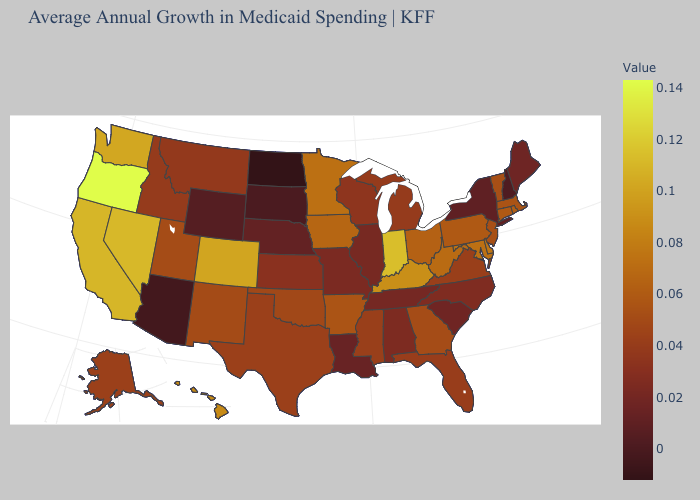Among the states that border Vermont , which have the highest value?
Answer briefly. Massachusetts. Does Utah have the highest value in the West?
Answer briefly. No. Does Nevada have the lowest value in the West?
Be succinct. No. Which states have the lowest value in the USA?
Short answer required. North Dakota. Does Oregon have the highest value in the USA?
Short answer required. Yes. 